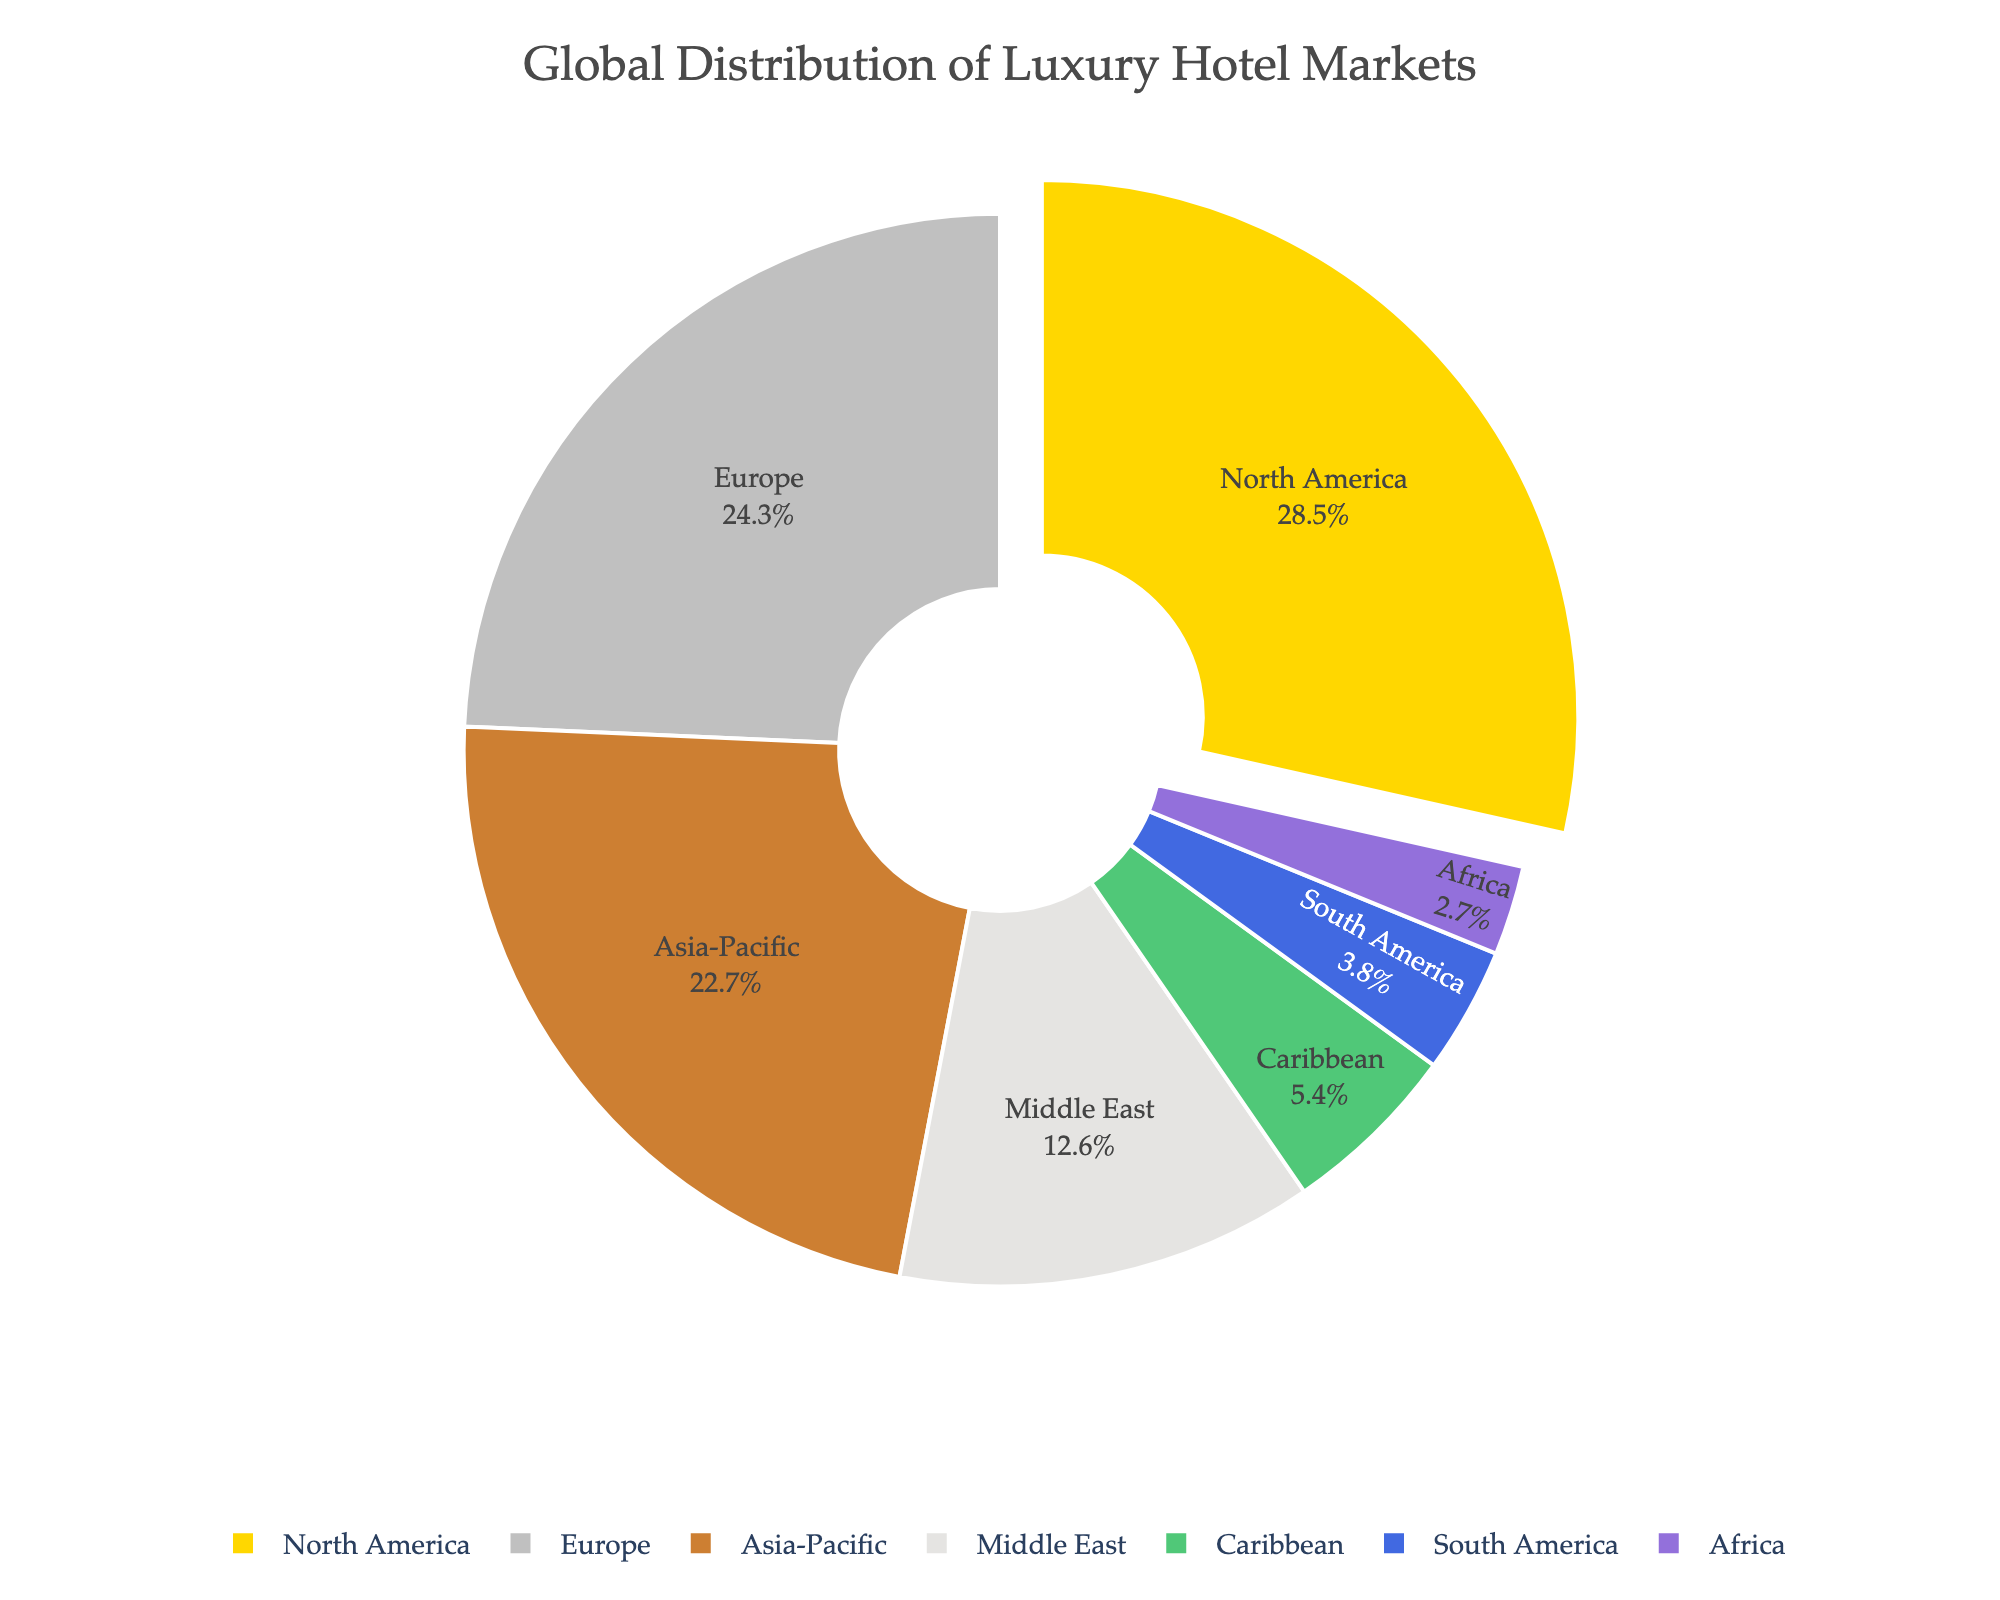Which region has the highest market share in luxury hotels? The largest segment in the pie chart belongs to North America, which has the highest market share.
Answer: North America Which regions have a combined market share of more than 50%? Adding the market shares: North America (28.5%) + Europe (24.3%) + Asia-Pacific (22.7%), and the total is 75.5%, which is more than 50%.
Answer: North America, Europe, Asia-Pacific What is the difference in market share between North America and Asia-Pacific? The market share of North America is 28.5% and that of Asia-Pacific is 22.7%. Subtracting these: 28.5% - 22.7% = 5.8%.
Answer: 5.8% Which region has the smallest market share? The smallest segment in the pie chart corresponds to Africa, indicating it has the smallest market share.
Answer: Africa What's the combined market share of the Middle East and the Caribbean? The market share of the Middle East is 12.6% and that of the Caribbean is 5.4%. Adding these: 12.6% + 5.4% = 18%.
Answer: 18% If you were to combine the market shares of South America and Africa, how would it compare to Europe’s market share? The market share of South America is 3.8% and Africa is 2.7%. Combined, this is 3.8% + 2.7% = 6.5%, which is less than Europe’s 24.3%.
Answer: Less than Europe Which three regions have the closest market shares to each other? By comparing the market shares: Europe (24.3%), Asia-Pacific (22.7%), and Middle East (12.6%) are closer to each other compared to other combinations.
Answer: Europe, Asia-Pacific, Middle East What is the visual color used for North America on the chart? The color used for North America is gold.
Answer: Gold 